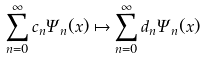<formula> <loc_0><loc_0><loc_500><loc_500>\sum _ { n = 0 } ^ { \infty } c _ { n } \Psi _ { n } ( x ) \mapsto \sum _ { n = 0 } ^ { \infty } d _ { n } \Psi _ { n } ( x )</formula> 